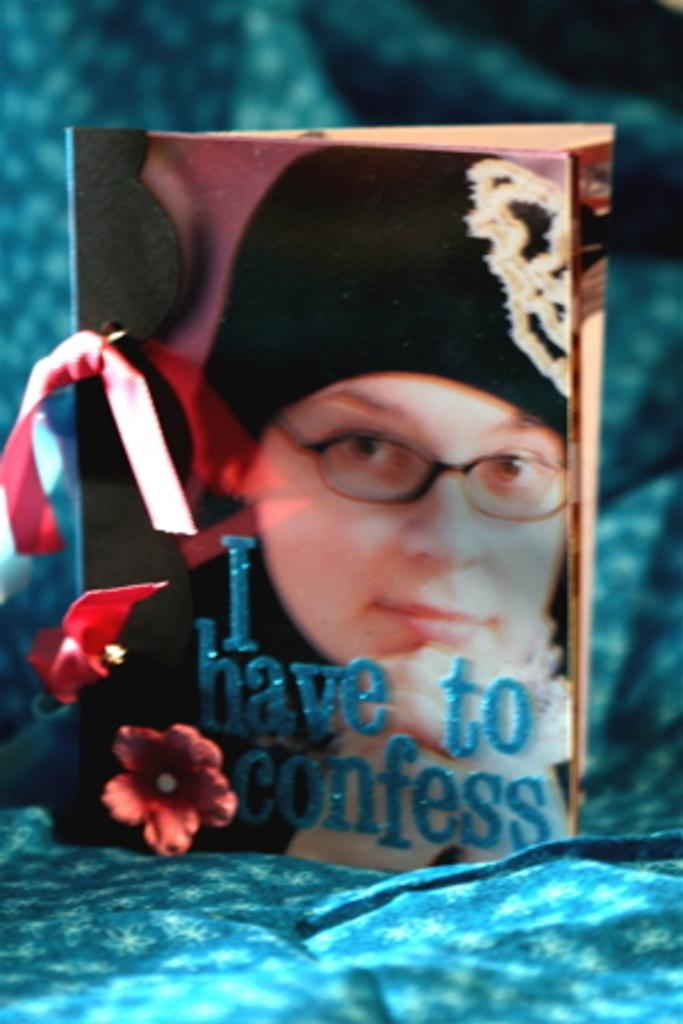What is the main object in the image? The image contains a greeting card. What is depicted on the greeting card? There is a photo of a person on the greeting card. Are there any words on the greeting card? Yes, there is text on the greeting card. What color is the cloth at the bottom of the image? The cloth at the bottom of the image is blue. What invention is being demonstrated by the person in the photo on the greeting card? There is no invention being demonstrated in the photo on the greeting card; it simply shows a person. Can you tell me how many cats are present in the image? There are no cats present in the image; it features a greeting card with a photo of a person. 